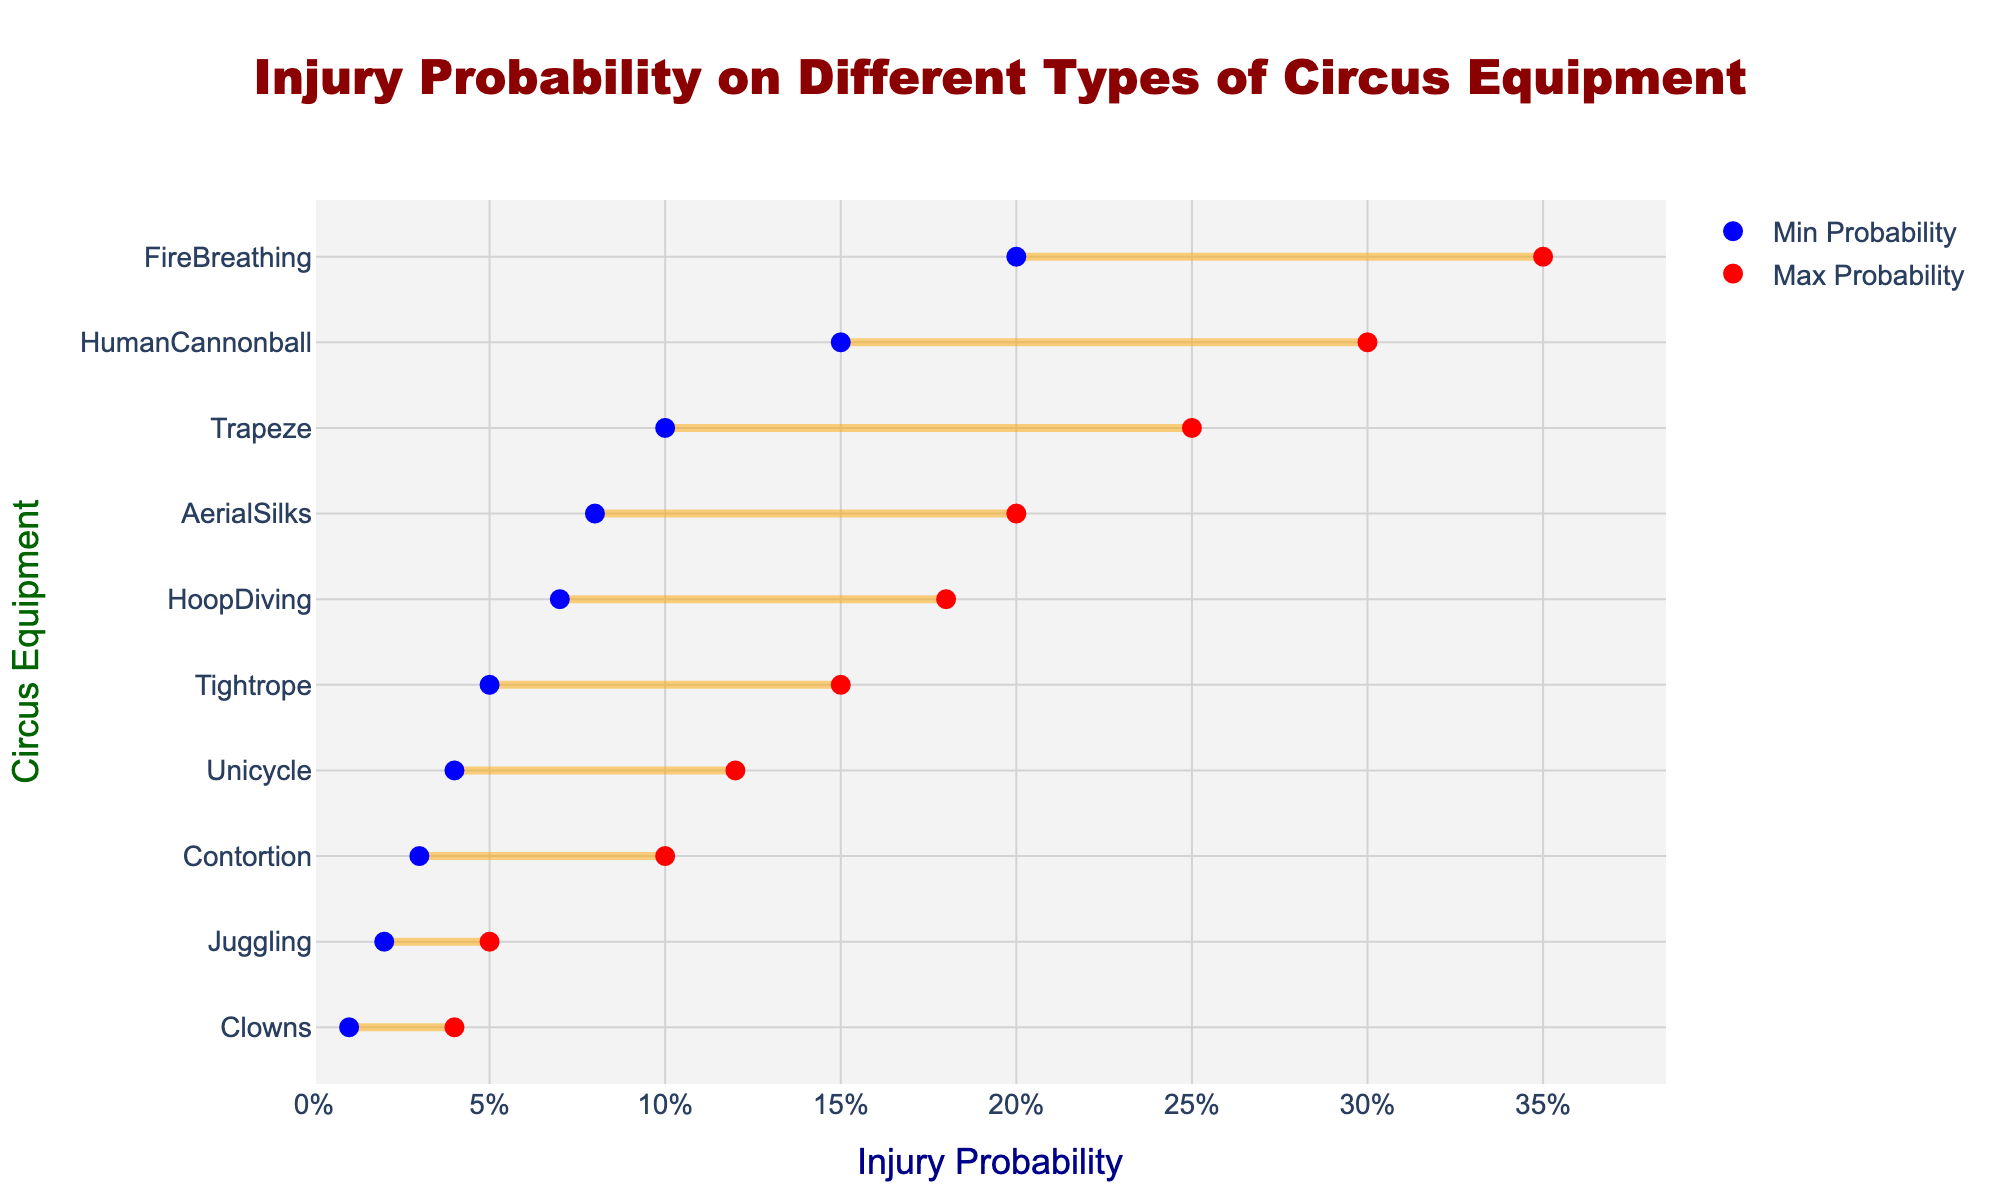What's the title of the figure? The title is located at the top of the figure, usually in a larger and bold font. It helps to summarize the subject of the plot.
Answer: Injury Probability on Different Types of Circus Equipment What are the x-axis and y-axis titles? The titles for the x-axis and y-axis are typically displayed directly beside the respective axes. They indicate what each axis represents.
Answer: x-axis: Injury Probability; y-axis: Circus Equipment Which piece of equipment has the highest maximum injury probability? To find the highest maximum injury probability, look at the red markers on the rightmost side of the plot and identify the corresponding label on the y-axis.
Answer: FireBreathing Which equipment has the smallest range of injury probabilities? Identify the equipment with the smallest distance between its blue and red markers horizontally. The smallest range will be the shortest line segment.
Answer: Clowns How does the injury probability range for Tightrope compare to that of Unicycle? Compare the lengths of the lines associated with Tightrope and Unicycle; the longer line indicates a greater range.
Answer: Tightrope has a longer range than Unicycle What is the equipment with the highest minimum injury probability? Look for the highest blue marker on the x-axis and identify the corresponding label on the y-axis.
Answer: FireBreathing Which two pieces of equipment have the closest minimum injury probabilities? Compare the blue markers across the plot and find the two that are closest together on the x-axis.
Answer: Tightrope and Unicycle What do the blue and red markers represent? The blue markers indicate the minimum injury probabilities, and the red markers indicate the maximum injury probabilities. This is likely explained in the legend or can be deduced from the context.
Answer: Blue: Min Probability; Red: Max Probability Between Human Cannonball and Trapeze, which equipment is less risky overall? Evaluate which one has a lower range of injury probabilities by comparing both the minimum and maximum values. Trapeze has a higher maximum probability than Human Cannonball.
Answer: Human Cannonball 